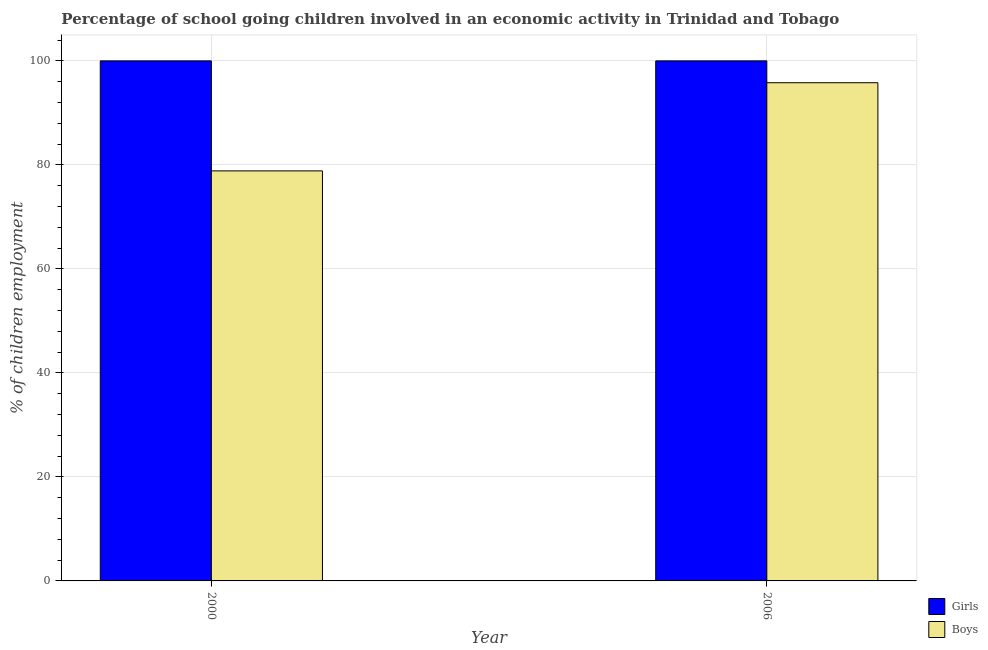Are the number of bars per tick equal to the number of legend labels?
Your answer should be very brief. Yes. How many bars are there on the 2nd tick from the left?
Your response must be concise. 2. What is the percentage of school going girls in 2000?
Your answer should be compact. 100. Across all years, what is the maximum percentage of school going girls?
Make the answer very short. 100. Across all years, what is the minimum percentage of school going girls?
Your answer should be very brief. 100. In which year was the percentage of school going boys maximum?
Your answer should be very brief. 2006. What is the total percentage of school going boys in the graph?
Your response must be concise. 174.65. What is the difference between the percentage of school going boys in 2000 and that in 2006?
Your answer should be very brief. -16.95. What is the difference between the percentage of school going boys in 2006 and the percentage of school going girls in 2000?
Give a very brief answer. 16.95. In how many years, is the percentage of school going boys greater than 36 %?
Make the answer very short. 2. In how many years, is the percentage of school going girls greater than the average percentage of school going girls taken over all years?
Your answer should be compact. 0. What does the 2nd bar from the left in 2000 represents?
Give a very brief answer. Boys. What does the 1st bar from the right in 2006 represents?
Provide a succinct answer. Boys. How many bars are there?
Provide a succinct answer. 4. Are all the bars in the graph horizontal?
Offer a terse response. No. How many years are there in the graph?
Ensure brevity in your answer.  2. What is the difference between two consecutive major ticks on the Y-axis?
Ensure brevity in your answer.  20. Are the values on the major ticks of Y-axis written in scientific E-notation?
Ensure brevity in your answer.  No. Where does the legend appear in the graph?
Provide a succinct answer. Bottom right. How are the legend labels stacked?
Your answer should be compact. Vertical. What is the title of the graph?
Your answer should be very brief. Percentage of school going children involved in an economic activity in Trinidad and Tobago. Does "Secondary education" appear as one of the legend labels in the graph?
Provide a succinct answer. No. What is the label or title of the Y-axis?
Your answer should be very brief. % of children employment. What is the % of children employment of Girls in 2000?
Your answer should be compact. 100. What is the % of children employment of Boys in 2000?
Give a very brief answer. 78.85. What is the % of children employment of Boys in 2006?
Give a very brief answer. 95.8. Across all years, what is the maximum % of children employment of Girls?
Give a very brief answer. 100. Across all years, what is the maximum % of children employment of Boys?
Your response must be concise. 95.8. Across all years, what is the minimum % of children employment of Girls?
Offer a terse response. 100. Across all years, what is the minimum % of children employment in Boys?
Your answer should be very brief. 78.85. What is the total % of children employment of Girls in the graph?
Keep it short and to the point. 200. What is the total % of children employment of Boys in the graph?
Offer a very short reply. 174.65. What is the difference between the % of children employment of Girls in 2000 and that in 2006?
Offer a terse response. 0. What is the difference between the % of children employment of Boys in 2000 and that in 2006?
Provide a succinct answer. -16.95. What is the average % of children employment in Girls per year?
Your answer should be compact. 100. What is the average % of children employment in Boys per year?
Ensure brevity in your answer.  87.32. In the year 2000, what is the difference between the % of children employment in Girls and % of children employment in Boys?
Make the answer very short. 21.15. What is the ratio of the % of children employment in Boys in 2000 to that in 2006?
Your response must be concise. 0.82. What is the difference between the highest and the second highest % of children employment of Boys?
Provide a succinct answer. 16.95. What is the difference between the highest and the lowest % of children employment of Girls?
Make the answer very short. 0. What is the difference between the highest and the lowest % of children employment of Boys?
Ensure brevity in your answer.  16.95. 